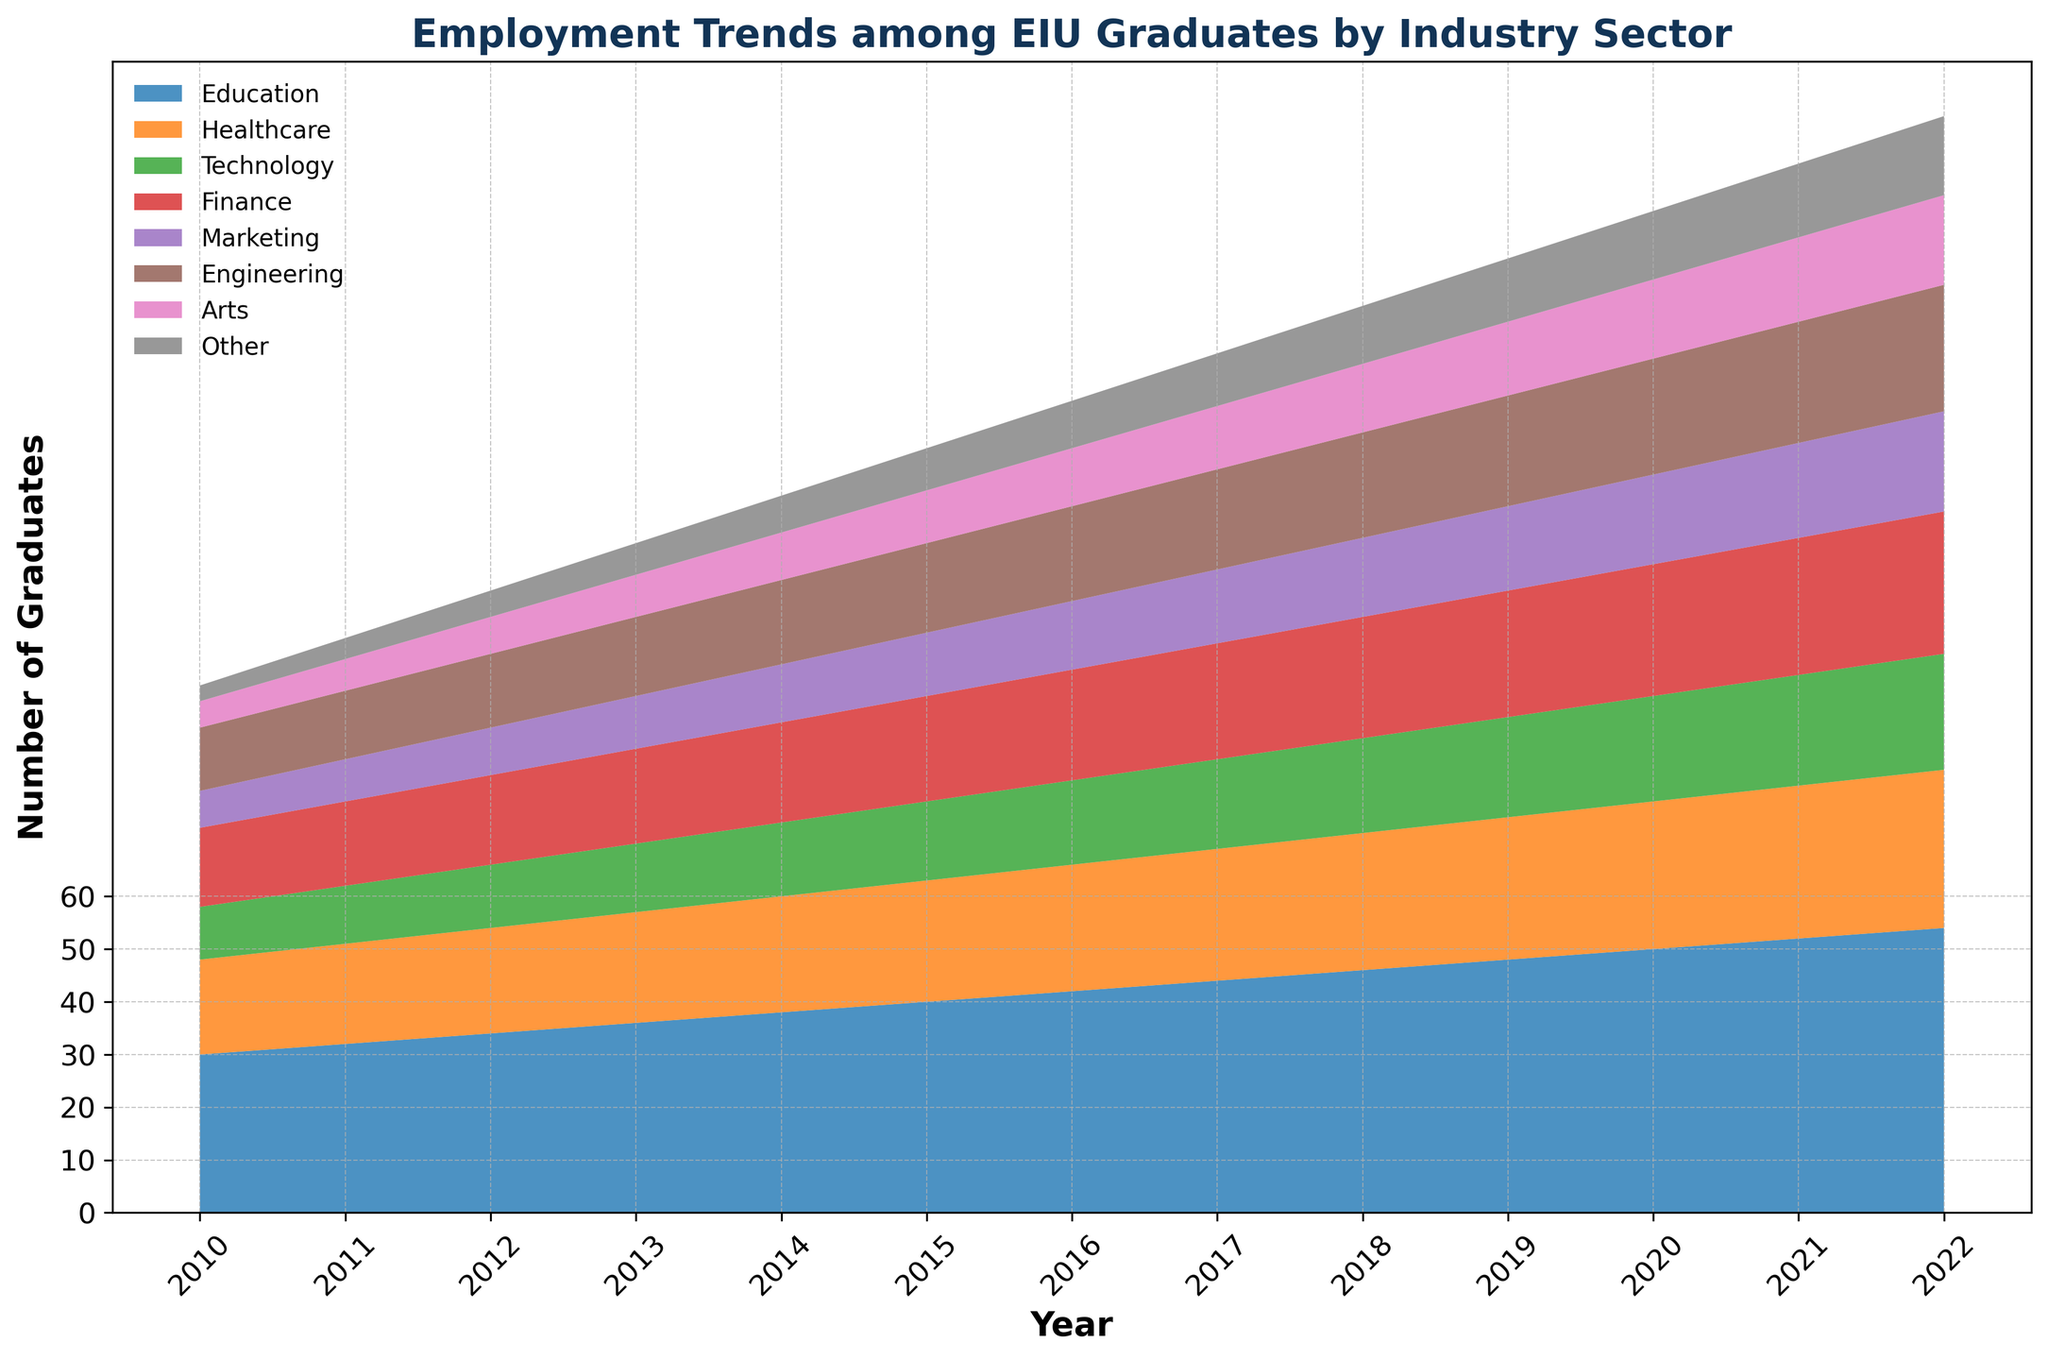What's the trend of Education employment from 2010 to 2022? When looking at the graph, identify the section corresponding to Education from 2010 to 2022 and observe the height changes. From 2010 to 2022, the area representing Education increases consistently from 30 to 54.
Answer: Increasing Which industry had the highest increase in the number of graduates from 2010 to 2022? Find the difference in the values from 2010 to 2022 for each industry. Education increased by 24 (54-30), making it the highest increase among the sectors.
Answer: Education In what year did the number of graduates in Healthcare first reach 25? Look at the Healthcare area in the chart. The number 25 appeared in 2017 for the first time, as indicated by the corresponding height on the y-axis.
Answer: 2017 How does the number of graduates in Technology in 2016 compare to Finance in the same year? Examine the heights of the Technology and Finance areas in 2016 and compare the values. In 2016, Technology had 16 graduates, and Finance had 21. Technology has fewer graduates compared to Finance in 2016.
Answer: Less than What is the sum of graduates in Marketing and Engineering in 2015? Add the values for Marketing and Engineering in 2015. Marketing had 12 graduates, and Engineering had 17 graduates. The sum is 12 + 17 = 29.
Answer: 29 Between 2015 and 2022, which industry saw the least growth? Calculate the growth for each sector between 2015 and 2022 and find the minimum. Arts grew from 10 to 17, which is the smallest growth of 7 graduates.
Answer: Arts Which sector had a greater number of graduates than Healthcare in 2020 but fewer in 2022? Identify sectors with more graduates than Healthcare (28) in 2020 but fewer than Healthcare (30) in 2022. Finance had more graduates in 2020 (25) and fewer in 2022 (27).
Answer: Finance What is the combined number of graduates in Other sectors over 2010-2012? Add the values from 2010, 2011, and 2012. Other had 3 graduates in 2010, 4 in 2011, and 5 in 2012. The total is 3 + 4 + 5 = 12.
Answer: 12 By how much did the number of graduates in Engineering grow between 2013 and 2019? Subtract the 2013 value from the 2019 value. Engineering grew from 15 in 2013 to 21 in 2019. The growth is 21 - 15 = 6.
Answer: 6 